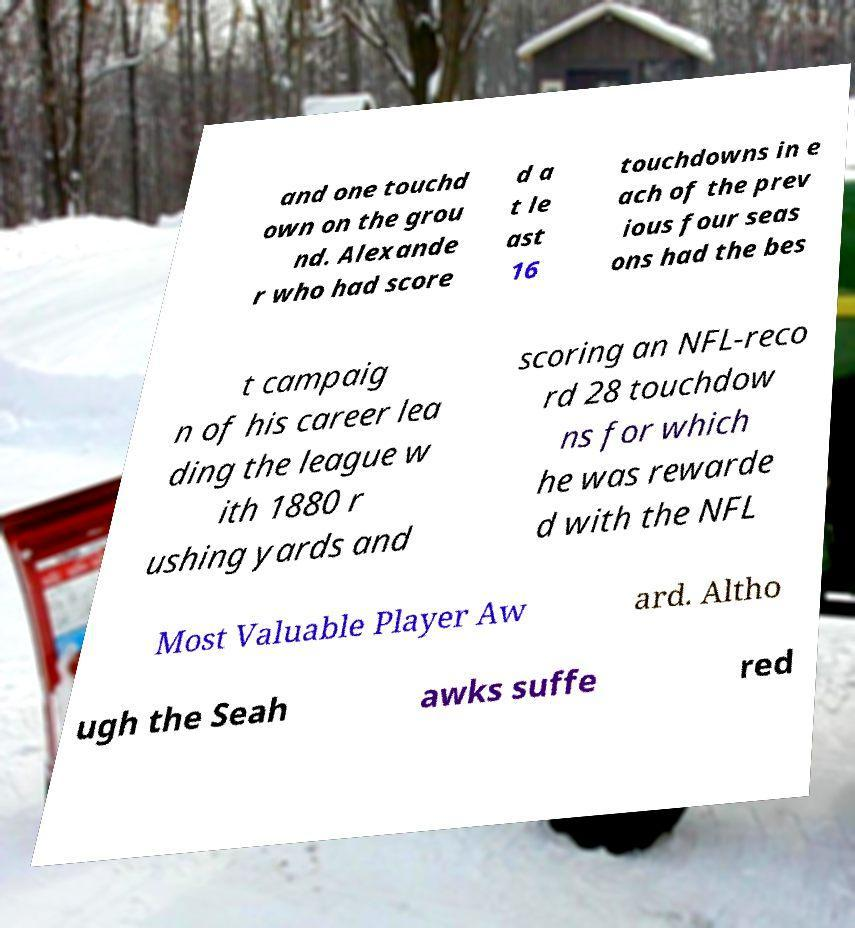What messages or text are displayed in this image? I need them in a readable, typed format. and one touchd own on the grou nd. Alexande r who had score d a t le ast 16 touchdowns in e ach of the prev ious four seas ons had the bes t campaig n of his career lea ding the league w ith 1880 r ushing yards and scoring an NFL-reco rd 28 touchdow ns for which he was rewarde d with the NFL Most Valuable Player Aw ard. Altho ugh the Seah awks suffe red 